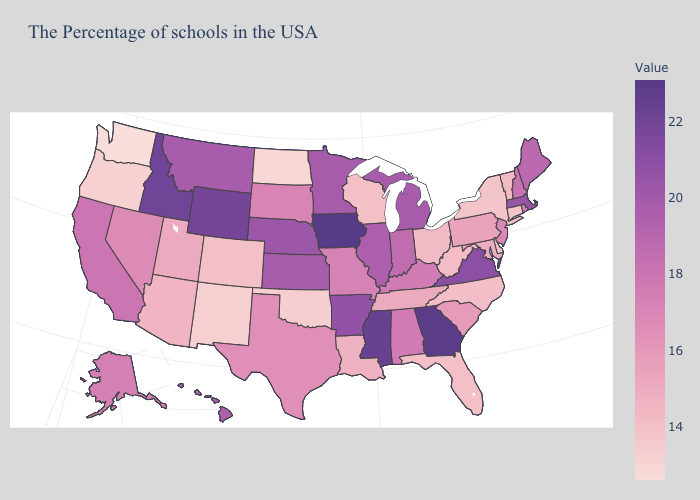Does the map have missing data?
Keep it brief. No. Among the states that border Michigan , does Wisconsin have the lowest value?
Keep it brief. Yes. Does North Dakota have the lowest value in the MidWest?
Answer briefly. Yes. Does Kentucky have the highest value in the USA?
Keep it brief. No. Does Oklahoma have a higher value than Maine?
Keep it brief. No. 